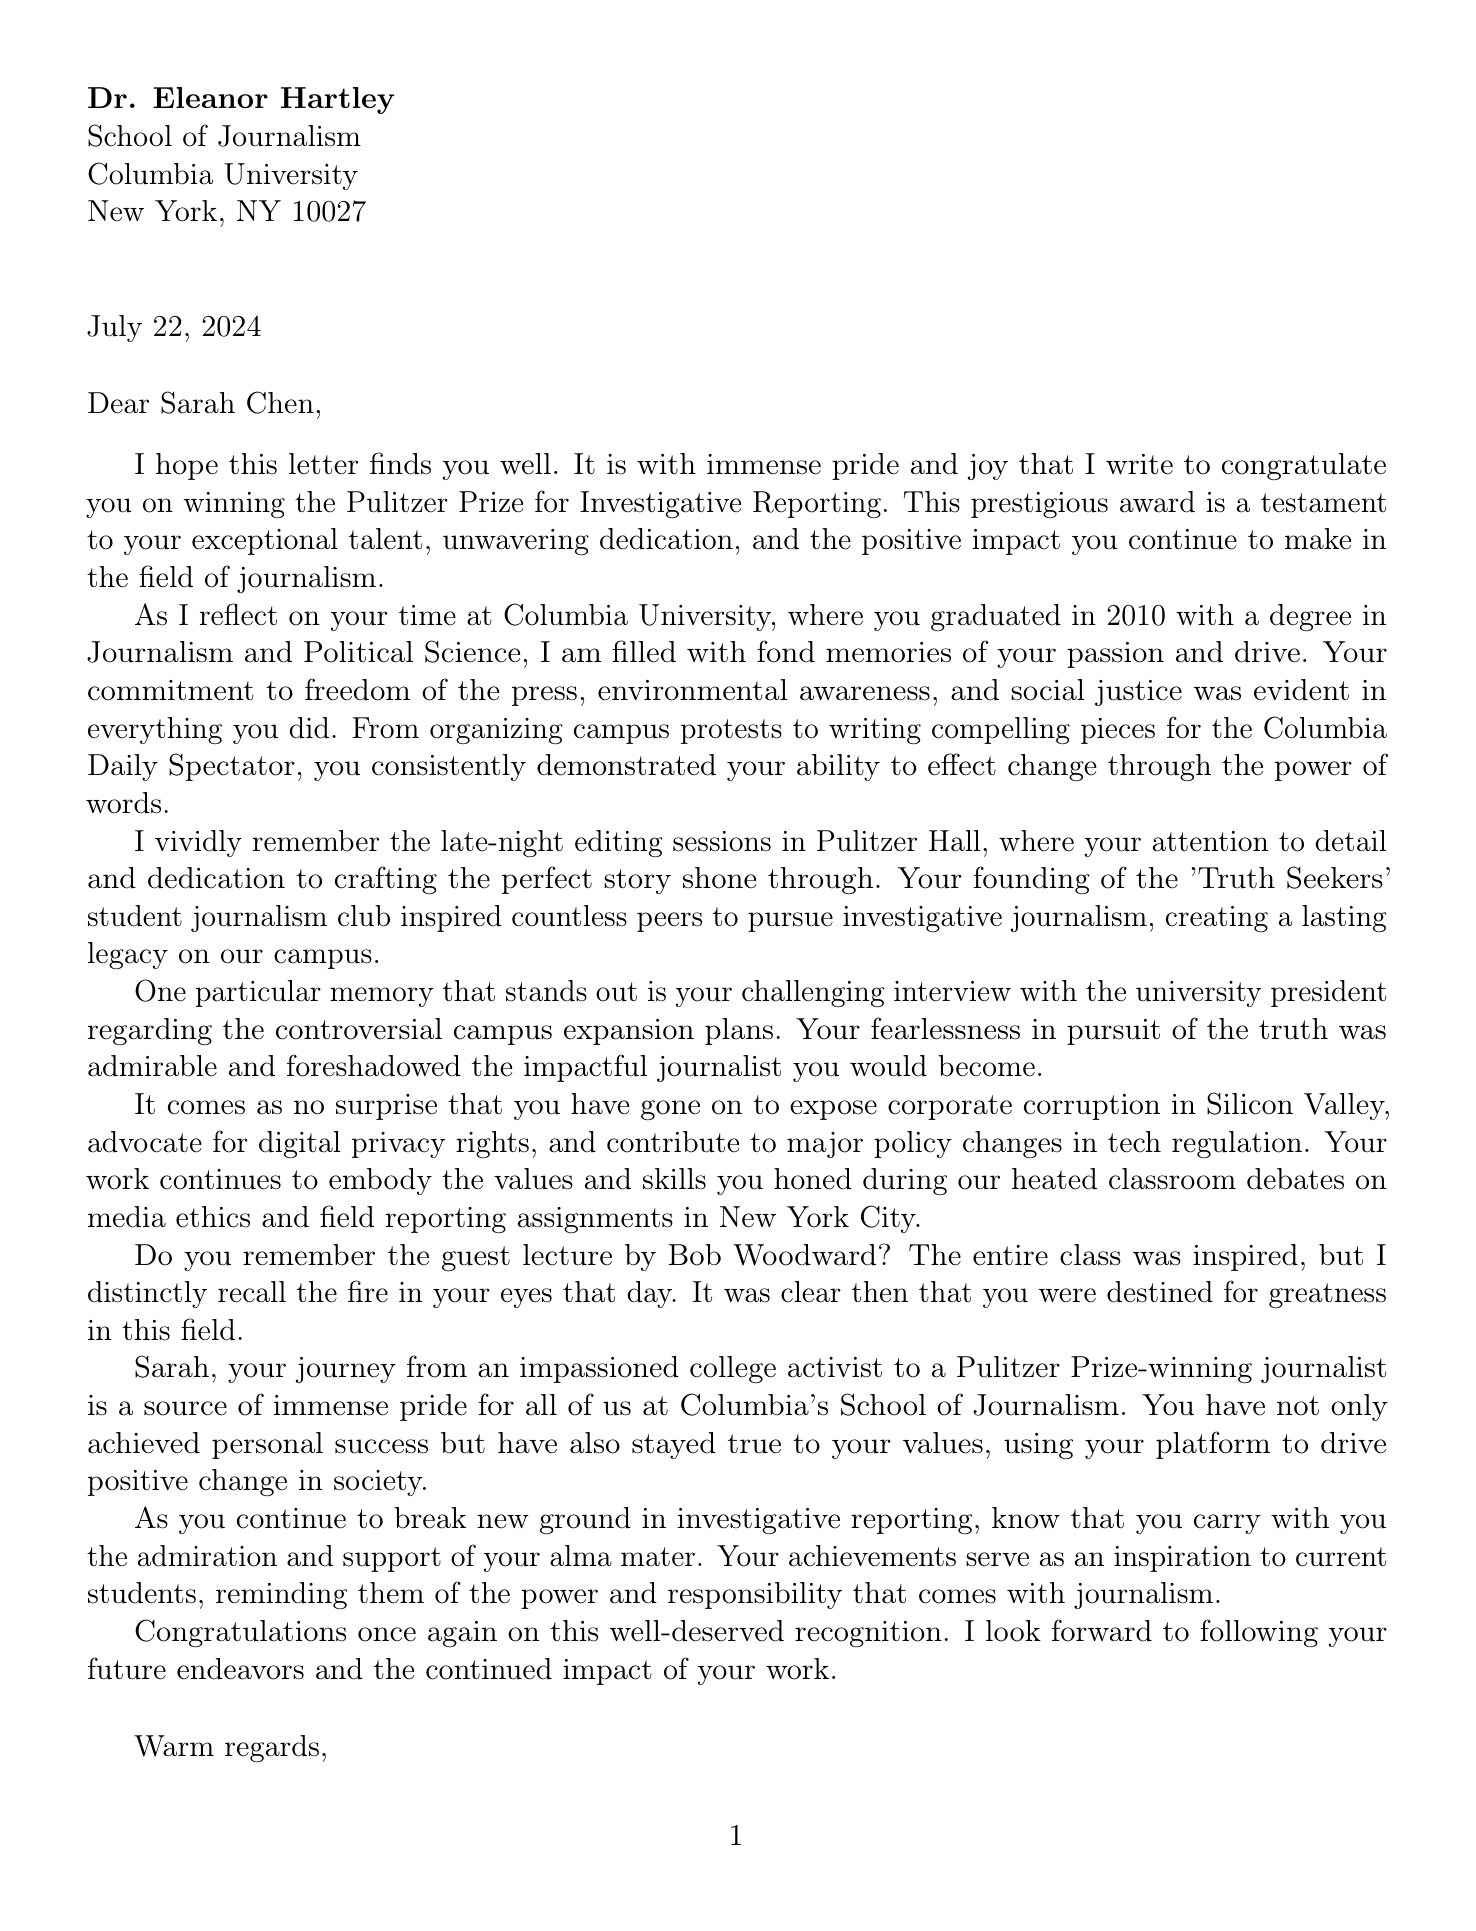What award did Sarah Chen win? The document states that Sarah Chen won the Pulitzer Prize for Investigative Reporting.
Answer: Pulitzer Prize for Investigative Reporting In what year did Sarah graduate from Columbia University? According to the document, Sarah graduated in 2010.
Answer: 2010 What causes did Sarah advocate for during her college days? The letter mentions her advocacy for freedom of the press, environmental awareness, and social justice.
Answer: Freedom of the press, Environmental awareness, Social justice Who wrote the letter to Sarah Chen? The document indicates that Dr. Eleanor Hartley wrote the letter.
Answer: Dr. Eleanor Hartley What major did Sarah pursue at Columbia? The document specifies that Sarah's major was Journalism and Political Science.
Answer: Journalism and Political Science How did Sarah's activism impact other students? The document notes that her activism increased student engagement in social issues and inspired others to pursue investigative journalism.
Answer: Increased student engagement in social issues What memorable event involved a challenging interview? The document recalls her challenging interview with the university president regarding the controversial campus expansion plans.
Answer: Challenging interview with university president What is one of Sarah's current achievements mentioned? The letter mentions her exposing corporate corruption in Silicon Valley as one of her current achievements.
Answer: Exposing corporate corruption in Silicon Valley What class activity inspired the entire class during Sarah's studies? The document references a guest lecture by Bob Woodward that inspired the whole class.
Answer: Guest lecture by Bob Woodward 